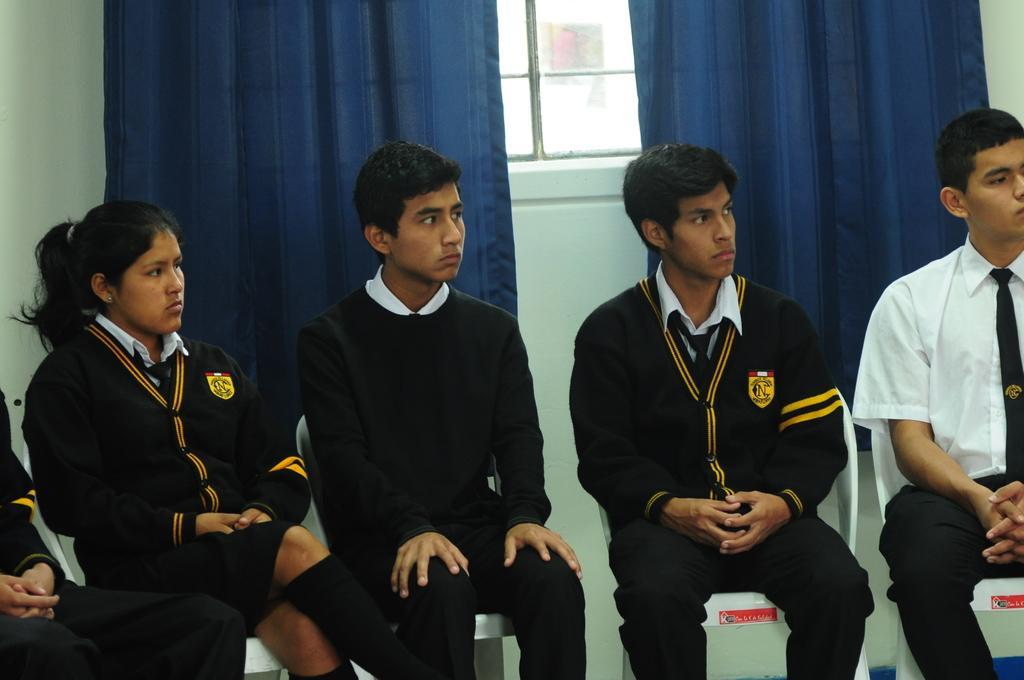Could you give a brief overview of what you see in this image? In this image, we can see people wearing uniforms and are sitting on the chairs and some of them are wearing coats. In the background, there are curtains and we can see a window and a wall. 